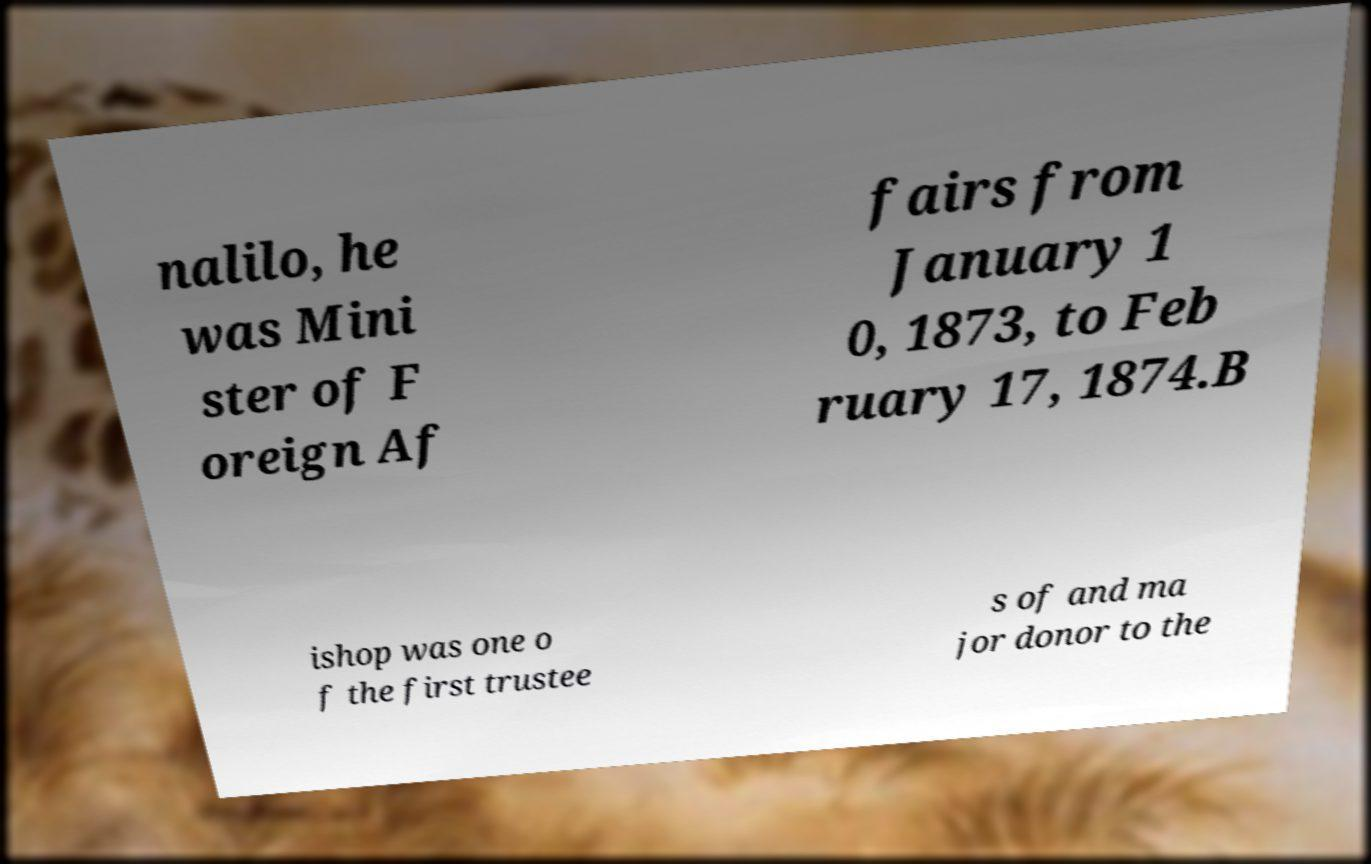Can you accurately transcribe the text from the provided image for me? nalilo, he was Mini ster of F oreign Af fairs from January 1 0, 1873, to Feb ruary 17, 1874.B ishop was one o f the first trustee s of and ma jor donor to the 